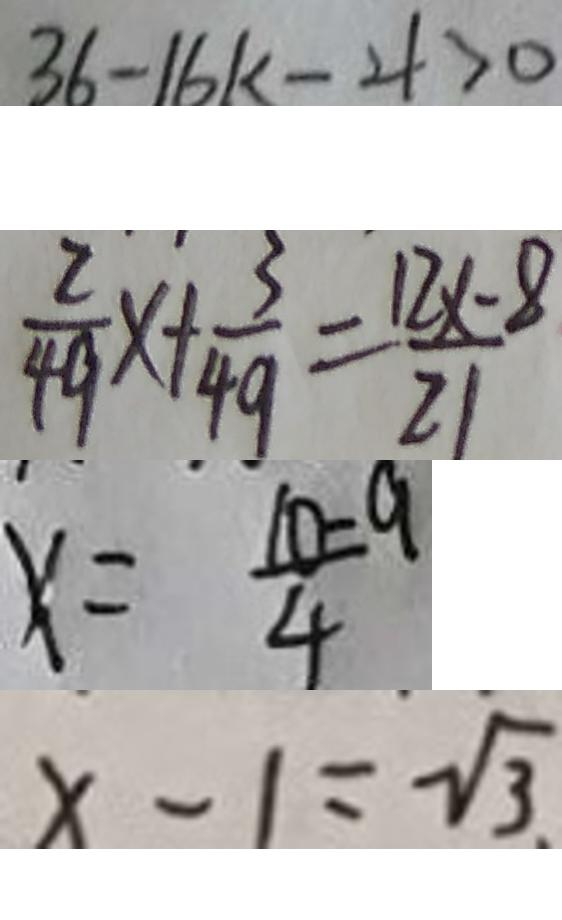<formula> <loc_0><loc_0><loc_500><loc_500>3 6 - 1 6 k - 4 > 0 
 \frac { 2 } { 4 9 } x + \frac { 3 } { 4 9 } = \frac { 1 2 x - 8 } { 2 1 } 
 x = \frac { 1 0 - 9 } { 4 } 
 x - 1 = \sqrt { 3 }</formula> 